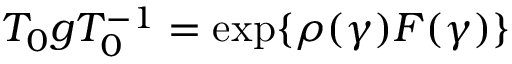Convert formula to latex. <formula><loc_0><loc_0><loc_500><loc_500>T _ { 0 } g T _ { 0 } ^ { - 1 } = \exp \{ \rho ( \gamma ) F ( \gamma ) \}</formula> 